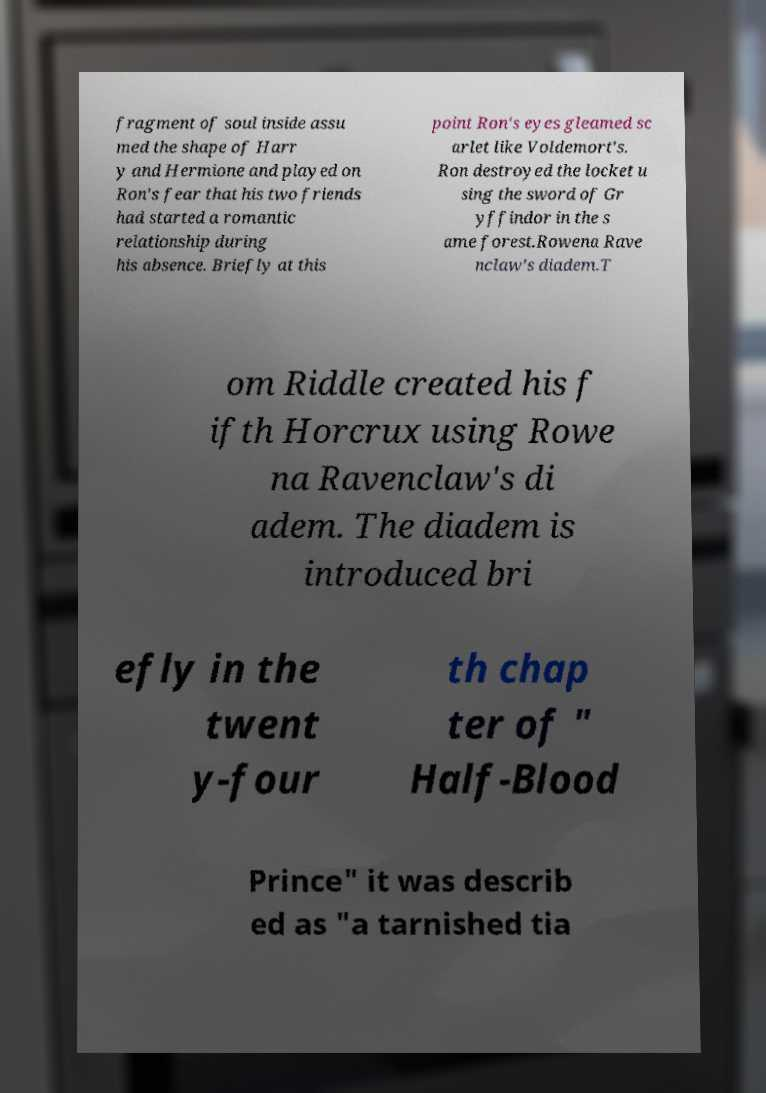There's text embedded in this image that I need extracted. Can you transcribe it verbatim? fragment of soul inside assu med the shape of Harr y and Hermione and played on Ron's fear that his two friends had started a romantic relationship during his absence. Briefly at this point Ron's eyes gleamed sc arlet like Voldemort's. Ron destroyed the locket u sing the sword of Gr yffindor in the s ame forest.Rowena Rave nclaw's diadem.T om Riddle created his f ifth Horcrux using Rowe na Ravenclaw's di adem. The diadem is introduced bri efly in the twent y-four th chap ter of " Half-Blood Prince" it was describ ed as "a tarnished tia 